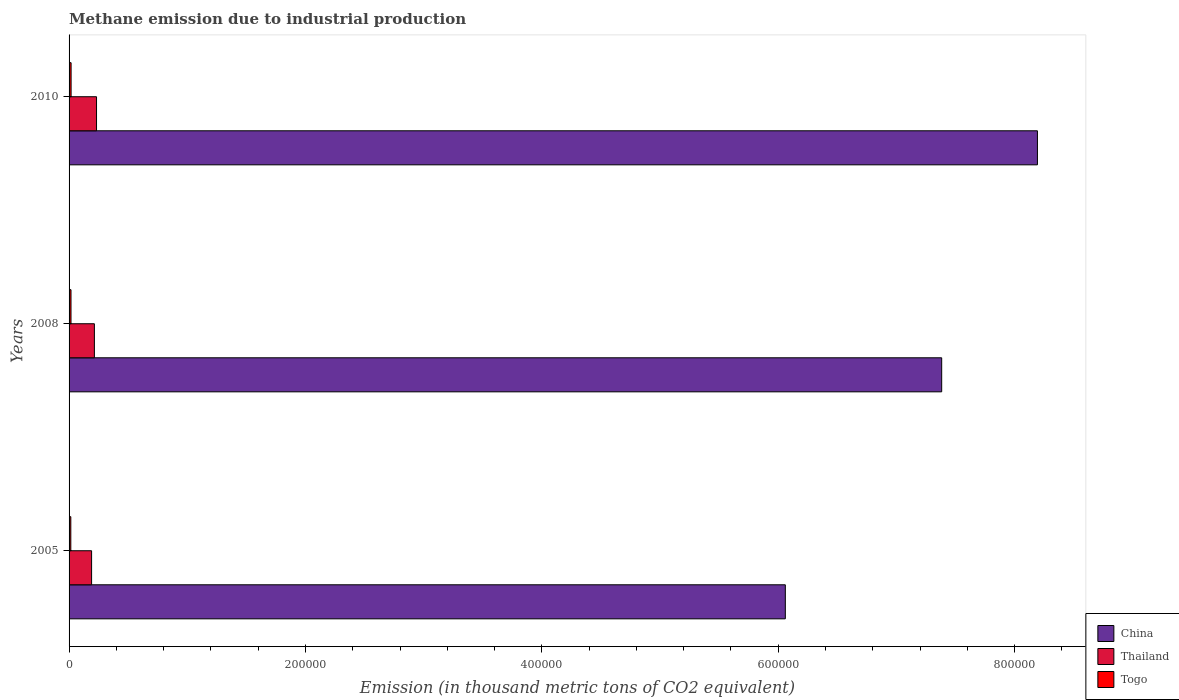How many groups of bars are there?
Keep it short and to the point. 3. Are the number of bars per tick equal to the number of legend labels?
Your answer should be very brief. Yes. Are the number of bars on each tick of the Y-axis equal?
Ensure brevity in your answer.  Yes. How many bars are there on the 2nd tick from the top?
Offer a terse response. 3. How many bars are there on the 3rd tick from the bottom?
Offer a very short reply. 3. What is the amount of methane emitted in Thailand in 2008?
Offer a very short reply. 2.14e+04. Across all years, what is the maximum amount of methane emitted in China?
Keep it short and to the point. 8.19e+05. Across all years, what is the minimum amount of methane emitted in Thailand?
Your response must be concise. 1.91e+04. In which year was the amount of methane emitted in Togo maximum?
Your answer should be compact. 2010. In which year was the amount of methane emitted in China minimum?
Provide a short and direct response. 2005. What is the total amount of methane emitted in Thailand in the graph?
Offer a terse response. 6.37e+04. What is the difference between the amount of methane emitted in Thailand in 2008 and that in 2010?
Provide a short and direct response. -1813.8. What is the difference between the amount of methane emitted in Thailand in 2005 and the amount of methane emitted in Togo in 2008?
Offer a terse response. 1.74e+04. What is the average amount of methane emitted in Togo per year?
Provide a short and direct response. 1606.7. In the year 2005, what is the difference between the amount of methane emitted in Togo and amount of methane emitted in Thailand?
Your answer should be compact. -1.76e+04. What is the ratio of the amount of methane emitted in Thailand in 2005 to that in 2008?
Provide a succinct answer. 0.89. Is the amount of methane emitted in Thailand in 2008 less than that in 2010?
Offer a terse response. Yes. What is the difference between the highest and the second highest amount of methane emitted in China?
Provide a short and direct response. 8.10e+04. What is the difference between the highest and the lowest amount of methane emitted in China?
Provide a succinct answer. 2.13e+05. In how many years, is the amount of methane emitted in China greater than the average amount of methane emitted in China taken over all years?
Your answer should be compact. 2. Is the sum of the amount of methane emitted in Thailand in 2005 and 2008 greater than the maximum amount of methane emitted in Togo across all years?
Provide a short and direct response. Yes. What does the 1st bar from the top in 2010 represents?
Ensure brevity in your answer.  Togo. What does the 3rd bar from the bottom in 2005 represents?
Offer a very short reply. Togo. How many bars are there?
Provide a short and direct response. 9. Are the values on the major ticks of X-axis written in scientific E-notation?
Keep it short and to the point. No. Does the graph contain grids?
Provide a short and direct response. No. How are the legend labels stacked?
Make the answer very short. Vertical. What is the title of the graph?
Make the answer very short. Methane emission due to industrial production. Does "Guinea-Bissau" appear as one of the legend labels in the graph?
Your answer should be compact. No. What is the label or title of the X-axis?
Your answer should be very brief. Emission (in thousand metric tons of CO2 equivalent). What is the Emission (in thousand metric tons of CO2 equivalent) of China in 2005?
Provide a short and direct response. 6.06e+05. What is the Emission (in thousand metric tons of CO2 equivalent) of Thailand in 2005?
Your response must be concise. 1.91e+04. What is the Emission (in thousand metric tons of CO2 equivalent) of Togo in 2005?
Your answer should be compact. 1478.8. What is the Emission (in thousand metric tons of CO2 equivalent) in China in 2008?
Provide a succinct answer. 7.38e+05. What is the Emission (in thousand metric tons of CO2 equivalent) of Thailand in 2008?
Make the answer very short. 2.14e+04. What is the Emission (in thousand metric tons of CO2 equivalent) of Togo in 2008?
Keep it short and to the point. 1635.6. What is the Emission (in thousand metric tons of CO2 equivalent) of China in 2010?
Give a very brief answer. 8.19e+05. What is the Emission (in thousand metric tons of CO2 equivalent) of Thailand in 2010?
Your answer should be very brief. 2.32e+04. What is the Emission (in thousand metric tons of CO2 equivalent) in Togo in 2010?
Offer a terse response. 1705.7. Across all years, what is the maximum Emission (in thousand metric tons of CO2 equivalent) in China?
Offer a terse response. 8.19e+05. Across all years, what is the maximum Emission (in thousand metric tons of CO2 equivalent) in Thailand?
Give a very brief answer. 2.32e+04. Across all years, what is the maximum Emission (in thousand metric tons of CO2 equivalent) in Togo?
Your answer should be very brief. 1705.7. Across all years, what is the minimum Emission (in thousand metric tons of CO2 equivalent) in China?
Provide a succinct answer. 6.06e+05. Across all years, what is the minimum Emission (in thousand metric tons of CO2 equivalent) in Thailand?
Your response must be concise. 1.91e+04. Across all years, what is the minimum Emission (in thousand metric tons of CO2 equivalent) of Togo?
Ensure brevity in your answer.  1478.8. What is the total Emission (in thousand metric tons of CO2 equivalent) in China in the graph?
Ensure brevity in your answer.  2.16e+06. What is the total Emission (in thousand metric tons of CO2 equivalent) of Thailand in the graph?
Offer a terse response. 6.37e+04. What is the total Emission (in thousand metric tons of CO2 equivalent) of Togo in the graph?
Give a very brief answer. 4820.1. What is the difference between the Emission (in thousand metric tons of CO2 equivalent) in China in 2005 and that in 2008?
Your response must be concise. -1.32e+05. What is the difference between the Emission (in thousand metric tons of CO2 equivalent) in Thailand in 2005 and that in 2008?
Your answer should be compact. -2358.4. What is the difference between the Emission (in thousand metric tons of CO2 equivalent) in Togo in 2005 and that in 2008?
Provide a short and direct response. -156.8. What is the difference between the Emission (in thousand metric tons of CO2 equivalent) in China in 2005 and that in 2010?
Your response must be concise. -2.13e+05. What is the difference between the Emission (in thousand metric tons of CO2 equivalent) of Thailand in 2005 and that in 2010?
Make the answer very short. -4172.2. What is the difference between the Emission (in thousand metric tons of CO2 equivalent) of Togo in 2005 and that in 2010?
Your answer should be compact. -226.9. What is the difference between the Emission (in thousand metric tons of CO2 equivalent) of China in 2008 and that in 2010?
Your answer should be compact. -8.10e+04. What is the difference between the Emission (in thousand metric tons of CO2 equivalent) in Thailand in 2008 and that in 2010?
Your response must be concise. -1813.8. What is the difference between the Emission (in thousand metric tons of CO2 equivalent) in Togo in 2008 and that in 2010?
Provide a short and direct response. -70.1. What is the difference between the Emission (in thousand metric tons of CO2 equivalent) in China in 2005 and the Emission (in thousand metric tons of CO2 equivalent) in Thailand in 2008?
Keep it short and to the point. 5.85e+05. What is the difference between the Emission (in thousand metric tons of CO2 equivalent) in China in 2005 and the Emission (in thousand metric tons of CO2 equivalent) in Togo in 2008?
Offer a terse response. 6.04e+05. What is the difference between the Emission (in thousand metric tons of CO2 equivalent) in Thailand in 2005 and the Emission (in thousand metric tons of CO2 equivalent) in Togo in 2008?
Offer a terse response. 1.74e+04. What is the difference between the Emission (in thousand metric tons of CO2 equivalent) in China in 2005 and the Emission (in thousand metric tons of CO2 equivalent) in Thailand in 2010?
Offer a terse response. 5.83e+05. What is the difference between the Emission (in thousand metric tons of CO2 equivalent) of China in 2005 and the Emission (in thousand metric tons of CO2 equivalent) of Togo in 2010?
Offer a very short reply. 6.04e+05. What is the difference between the Emission (in thousand metric tons of CO2 equivalent) in Thailand in 2005 and the Emission (in thousand metric tons of CO2 equivalent) in Togo in 2010?
Keep it short and to the point. 1.74e+04. What is the difference between the Emission (in thousand metric tons of CO2 equivalent) of China in 2008 and the Emission (in thousand metric tons of CO2 equivalent) of Thailand in 2010?
Provide a succinct answer. 7.15e+05. What is the difference between the Emission (in thousand metric tons of CO2 equivalent) in China in 2008 and the Emission (in thousand metric tons of CO2 equivalent) in Togo in 2010?
Keep it short and to the point. 7.37e+05. What is the difference between the Emission (in thousand metric tons of CO2 equivalent) of Thailand in 2008 and the Emission (in thousand metric tons of CO2 equivalent) of Togo in 2010?
Offer a very short reply. 1.97e+04. What is the average Emission (in thousand metric tons of CO2 equivalent) in China per year?
Your answer should be very brief. 7.21e+05. What is the average Emission (in thousand metric tons of CO2 equivalent) of Thailand per year?
Provide a succinct answer. 2.12e+04. What is the average Emission (in thousand metric tons of CO2 equivalent) of Togo per year?
Offer a very short reply. 1606.7. In the year 2005, what is the difference between the Emission (in thousand metric tons of CO2 equivalent) of China and Emission (in thousand metric tons of CO2 equivalent) of Thailand?
Your answer should be very brief. 5.87e+05. In the year 2005, what is the difference between the Emission (in thousand metric tons of CO2 equivalent) in China and Emission (in thousand metric tons of CO2 equivalent) in Togo?
Provide a short and direct response. 6.05e+05. In the year 2005, what is the difference between the Emission (in thousand metric tons of CO2 equivalent) in Thailand and Emission (in thousand metric tons of CO2 equivalent) in Togo?
Make the answer very short. 1.76e+04. In the year 2008, what is the difference between the Emission (in thousand metric tons of CO2 equivalent) of China and Emission (in thousand metric tons of CO2 equivalent) of Thailand?
Your response must be concise. 7.17e+05. In the year 2008, what is the difference between the Emission (in thousand metric tons of CO2 equivalent) of China and Emission (in thousand metric tons of CO2 equivalent) of Togo?
Your response must be concise. 7.37e+05. In the year 2008, what is the difference between the Emission (in thousand metric tons of CO2 equivalent) in Thailand and Emission (in thousand metric tons of CO2 equivalent) in Togo?
Your answer should be compact. 1.98e+04. In the year 2010, what is the difference between the Emission (in thousand metric tons of CO2 equivalent) in China and Emission (in thousand metric tons of CO2 equivalent) in Thailand?
Provide a succinct answer. 7.96e+05. In the year 2010, what is the difference between the Emission (in thousand metric tons of CO2 equivalent) of China and Emission (in thousand metric tons of CO2 equivalent) of Togo?
Your answer should be very brief. 8.18e+05. In the year 2010, what is the difference between the Emission (in thousand metric tons of CO2 equivalent) of Thailand and Emission (in thousand metric tons of CO2 equivalent) of Togo?
Offer a very short reply. 2.15e+04. What is the ratio of the Emission (in thousand metric tons of CO2 equivalent) in China in 2005 to that in 2008?
Ensure brevity in your answer.  0.82. What is the ratio of the Emission (in thousand metric tons of CO2 equivalent) of Thailand in 2005 to that in 2008?
Your response must be concise. 0.89. What is the ratio of the Emission (in thousand metric tons of CO2 equivalent) of Togo in 2005 to that in 2008?
Provide a short and direct response. 0.9. What is the ratio of the Emission (in thousand metric tons of CO2 equivalent) in China in 2005 to that in 2010?
Give a very brief answer. 0.74. What is the ratio of the Emission (in thousand metric tons of CO2 equivalent) of Thailand in 2005 to that in 2010?
Make the answer very short. 0.82. What is the ratio of the Emission (in thousand metric tons of CO2 equivalent) in Togo in 2005 to that in 2010?
Your answer should be very brief. 0.87. What is the ratio of the Emission (in thousand metric tons of CO2 equivalent) of China in 2008 to that in 2010?
Offer a very short reply. 0.9. What is the ratio of the Emission (in thousand metric tons of CO2 equivalent) in Thailand in 2008 to that in 2010?
Provide a succinct answer. 0.92. What is the ratio of the Emission (in thousand metric tons of CO2 equivalent) in Togo in 2008 to that in 2010?
Ensure brevity in your answer.  0.96. What is the difference between the highest and the second highest Emission (in thousand metric tons of CO2 equivalent) of China?
Give a very brief answer. 8.10e+04. What is the difference between the highest and the second highest Emission (in thousand metric tons of CO2 equivalent) of Thailand?
Provide a succinct answer. 1813.8. What is the difference between the highest and the second highest Emission (in thousand metric tons of CO2 equivalent) in Togo?
Your answer should be compact. 70.1. What is the difference between the highest and the lowest Emission (in thousand metric tons of CO2 equivalent) of China?
Offer a terse response. 2.13e+05. What is the difference between the highest and the lowest Emission (in thousand metric tons of CO2 equivalent) of Thailand?
Offer a terse response. 4172.2. What is the difference between the highest and the lowest Emission (in thousand metric tons of CO2 equivalent) of Togo?
Your response must be concise. 226.9. 